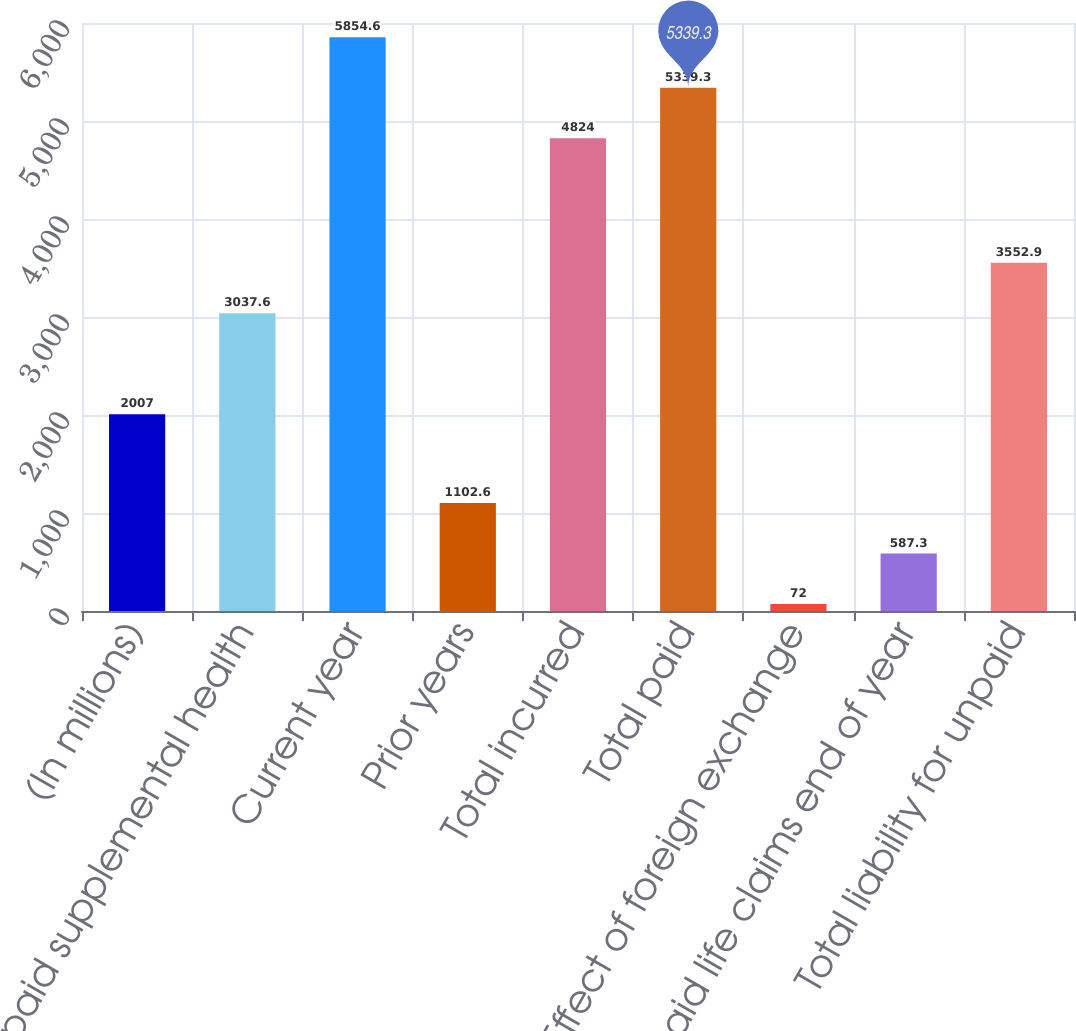Convert chart to OTSL. <chart><loc_0><loc_0><loc_500><loc_500><bar_chart><fcel>(In millions)<fcel>Unpaid supplemental health<fcel>Current year<fcel>Prior years<fcel>Total incurred<fcel>Total paid<fcel>Effect of foreign exchange<fcel>Unpaid life claims end of year<fcel>Total liability for unpaid<nl><fcel>2007<fcel>3037.6<fcel>5854.6<fcel>1102.6<fcel>4824<fcel>5339.3<fcel>72<fcel>587.3<fcel>3552.9<nl></chart> 